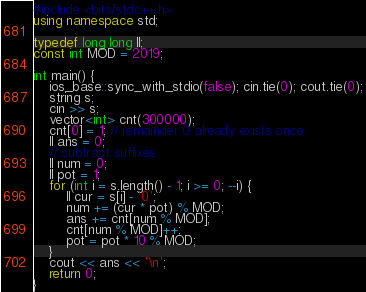Convert code to text. <code><loc_0><loc_0><loc_500><loc_500><_C++_>#include <bits/stdc++.h>
using namespace std;

typedef long long ll;
const int MOD = 2019;

int main() {
    ios_base::sync_with_stdio(false); cin.tie(0); cout.tie(0);
    string s;
    cin >> s;
    vector<int> cnt(300000);
    cnt[0] = 1; // remainder 0 already exists once
    ll ans = 0;
    // subtract suffixes
    ll num = 0;
    ll pot = 1;
    for (int i = s.length() - 1; i >= 0; --i) {
        ll cur = s[i] - '0';
        num += (cur * pot) % MOD;
        ans += cnt[num % MOD];
        cnt[num % MOD]++;
        pot = pot * 10 % MOD;
    }
    cout << ans << '\n';
    return 0;
}</code> 